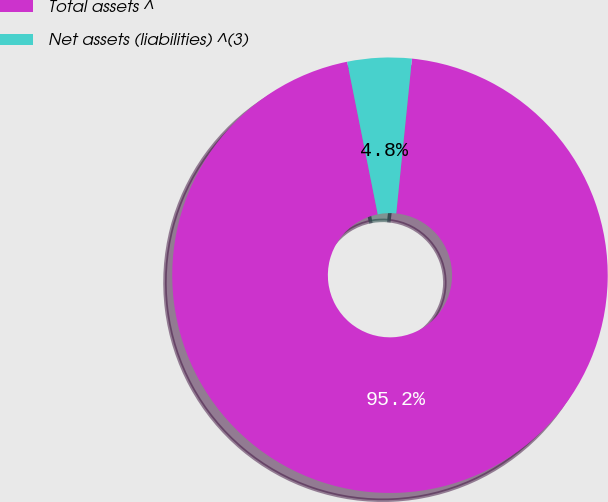Convert chart. <chart><loc_0><loc_0><loc_500><loc_500><pie_chart><fcel>Total assets ^<fcel>Net assets (liabilities) ^(3)<nl><fcel>95.24%<fcel>4.76%<nl></chart> 